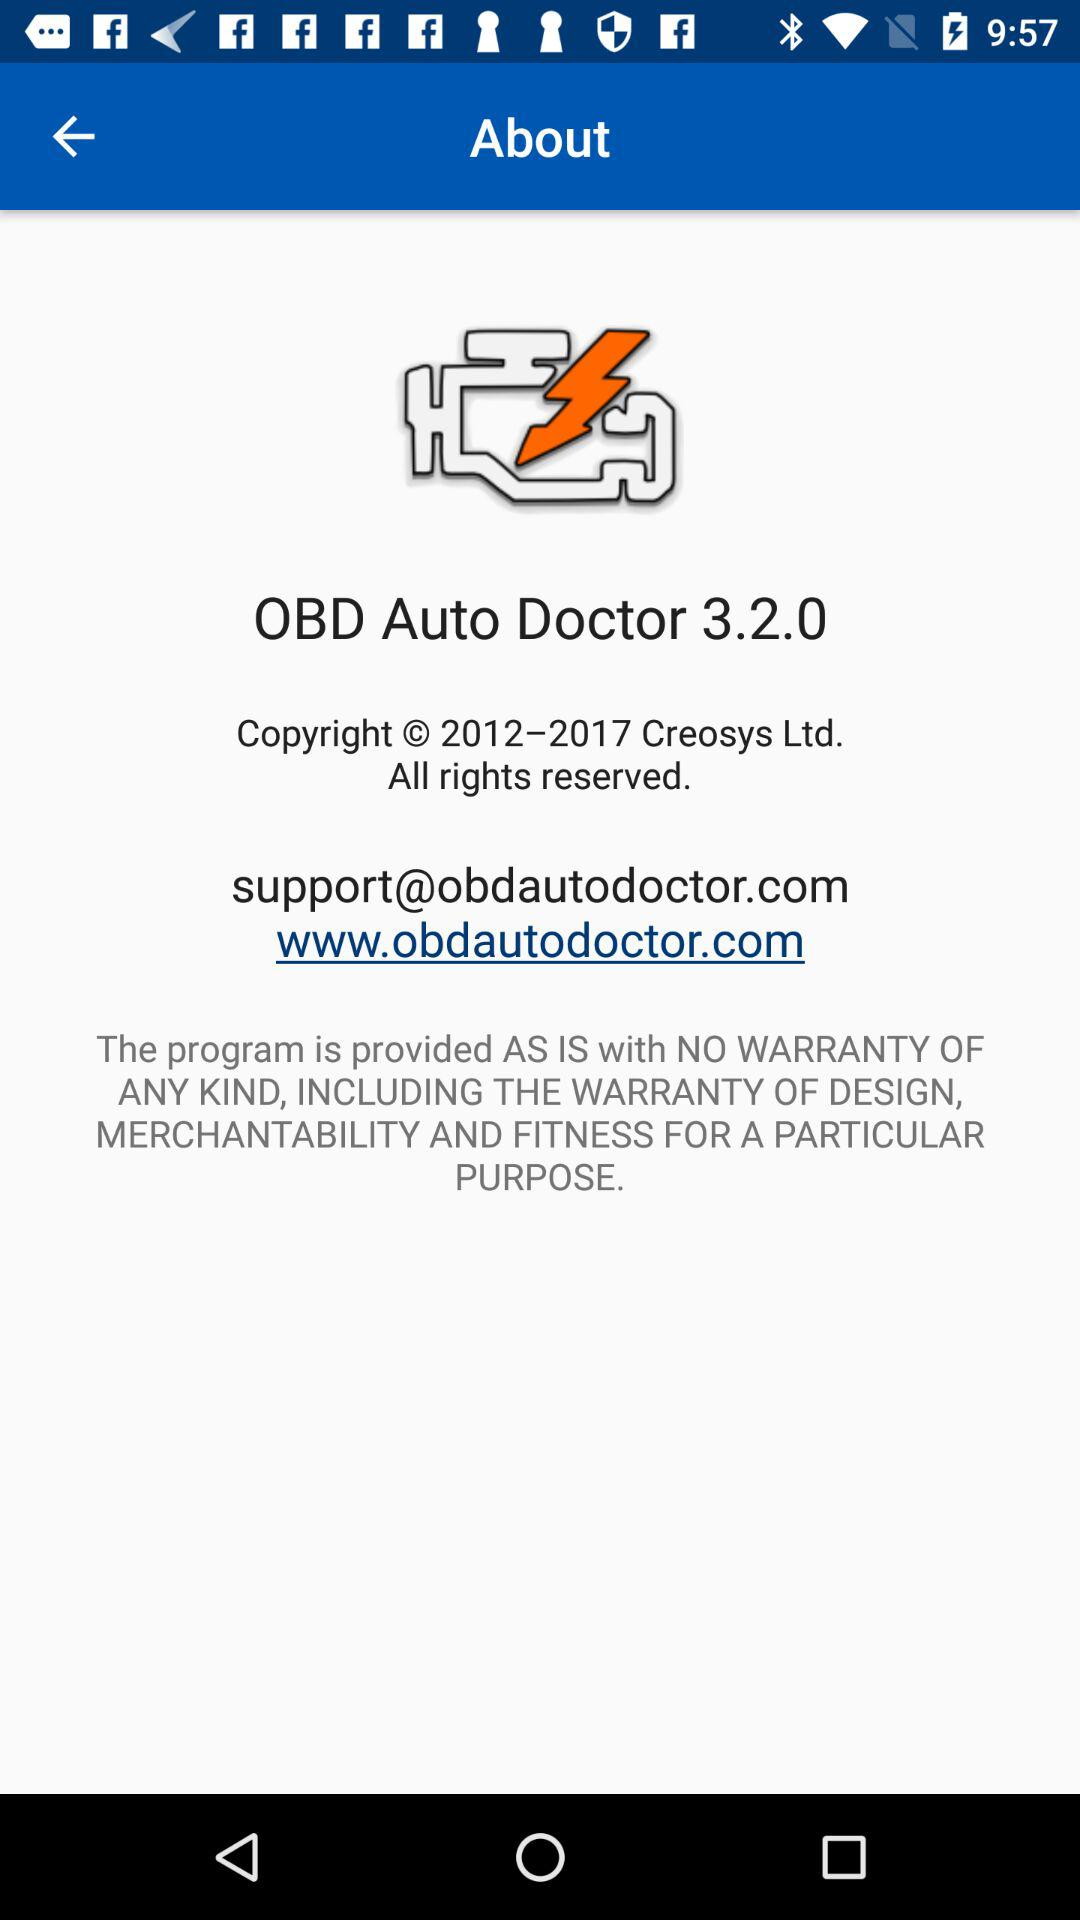What is the copyright year? The copyright years are from 2012 to 2017. 